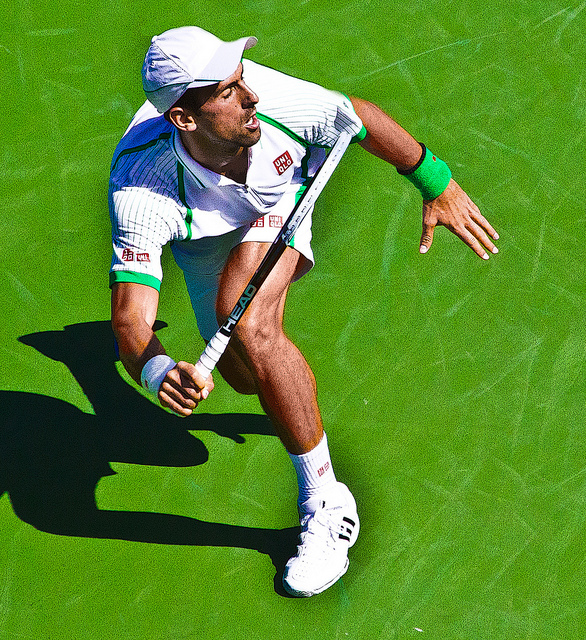Please identify all text content in this image. HEAD 